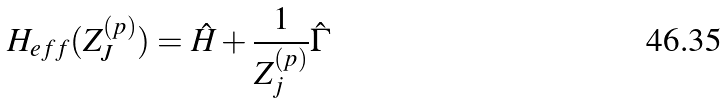Convert formula to latex. <formula><loc_0><loc_0><loc_500><loc_500>H _ { e f f } ( Z _ { J } ^ { ( p ) } ) = \hat { H } + \frac { 1 } { Z _ { j } ^ { ( p ) } } \hat { \Gamma }</formula> 